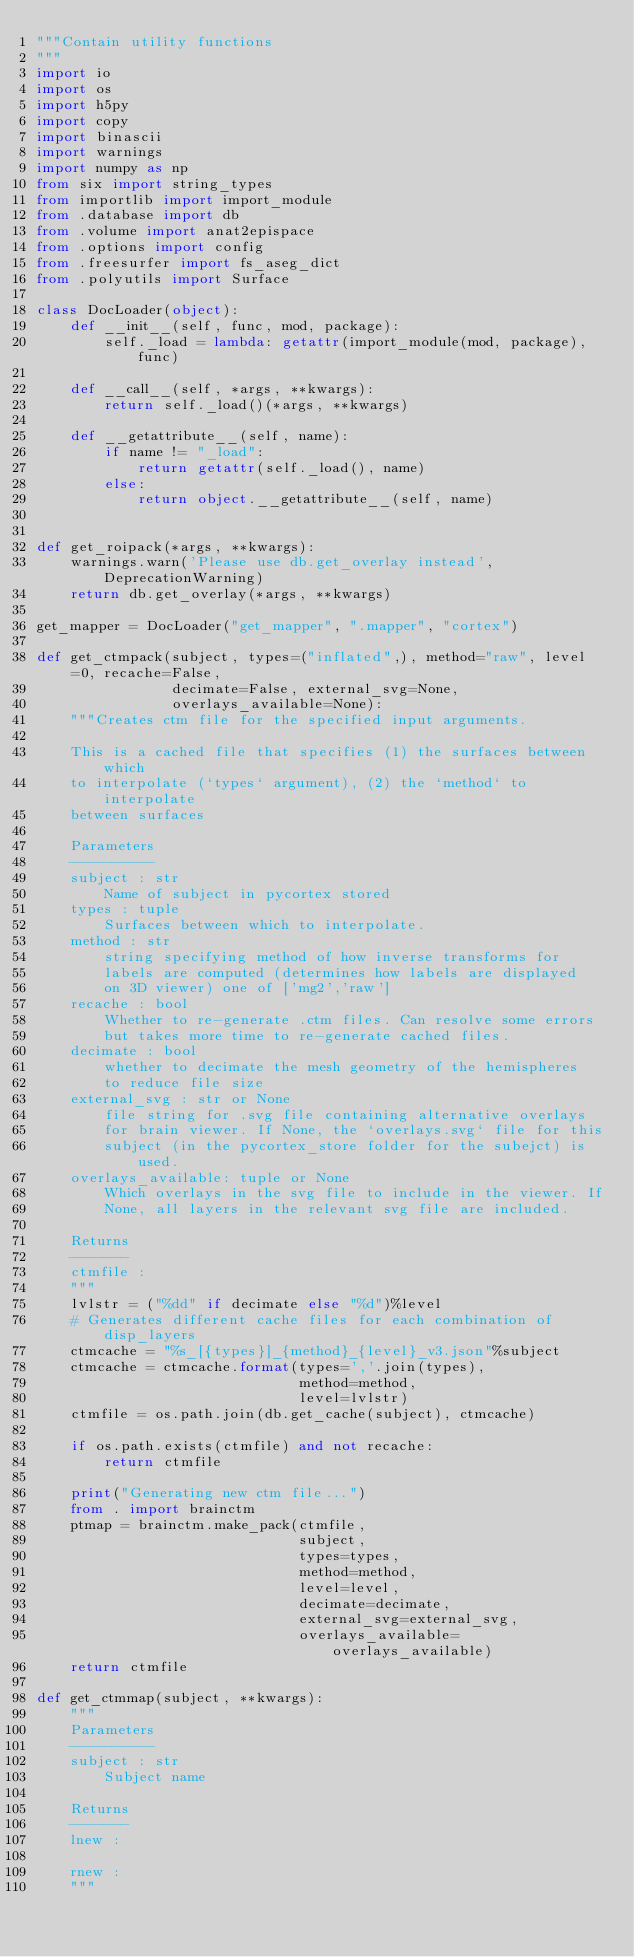Convert code to text. <code><loc_0><loc_0><loc_500><loc_500><_Python_>"""Contain utility functions
"""
import io
import os
import h5py
import copy
import binascii
import warnings
import numpy as np
from six import string_types
from importlib import import_module
from .database import db
from .volume import anat2epispace
from .options import config
from .freesurfer import fs_aseg_dict
from .polyutils import Surface 

class DocLoader(object):
    def __init__(self, func, mod, package):
        self._load = lambda: getattr(import_module(mod, package), func)

    def __call__(self, *args, **kwargs):
        return self._load()(*args, **kwargs)

    def __getattribute__(self, name):
        if name != "_load":
            return getattr(self._load(), name)
        else:
            return object.__getattribute__(self, name)


def get_roipack(*args, **kwargs):
    warnings.warn('Please use db.get_overlay instead', DeprecationWarning)
    return db.get_overlay(*args, **kwargs)

get_mapper = DocLoader("get_mapper", ".mapper", "cortex")

def get_ctmpack(subject, types=("inflated",), method="raw", level=0, recache=False,
                decimate=False, external_svg=None,
                overlays_available=None):
    """Creates ctm file for the specified input arguments.

    This is a cached file that specifies (1) the surfaces between which
    to interpolate (`types` argument), (2) the `method` to interpolate
    between surfaces

    Parameters
    ----------
    subject : str
        Name of subject in pycortex stored
    types : tuple
        Surfaces between which to interpolate.
    method : str
        string specifying method of how inverse transforms for
        labels are computed (determines how labels are displayed
        on 3D viewer) one of ['mg2','raw']
    recache : bool
        Whether to re-generate .ctm files. Can resolve some errors 
        but takes more time to re-generate cached files.
    decimate : bool
        whether to decimate the mesh geometry of the hemispheres
        to reduce file size
    external_svg : str or None
        file string for .svg file containing alternative overlays 
        for brain viewer. If None, the `overlays.svg` file for this
        subject (in the pycortex_store folder for the subejct) is used.
    overlays_available: tuple or None
        Which overlays in the svg file to include in the viewer. If
        None, all layers in the relevant svg file are included.

    Returns
    -------
    ctmfile :
    """
    lvlstr = ("%dd" if decimate else "%d")%level
    # Generates different cache files for each combination of disp_layers
    ctmcache = "%s_[{types}]_{method}_{level}_v3.json"%subject
    ctmcache = ctmcache.format(types=','.join(types),
                               method=method,
                               level=lvlstr)
    ctmfile = os.path.join(db.get_cache(subject), ctmcache)

    if os.path.exists(ctmfile) and not recache:
        return ctmfile

    print("Generating new ctm file...")
    from . import brainctm
    ptmap = brainctm.make_pack(ctmfile,
                               subject,
                               types=types,
                               method=method,
                               level=level,
                               decimate=decimate,
                               external_svg=external_svg,
                               overlays_available=overlays_available)
    return ctmfile

def get_ctmmap(subject, **kwargs):
    """
    Parameters
    ----------
    subject : str
        Subject name

    Returns
    -------
    lnew :

    rnew :
    """</code> 